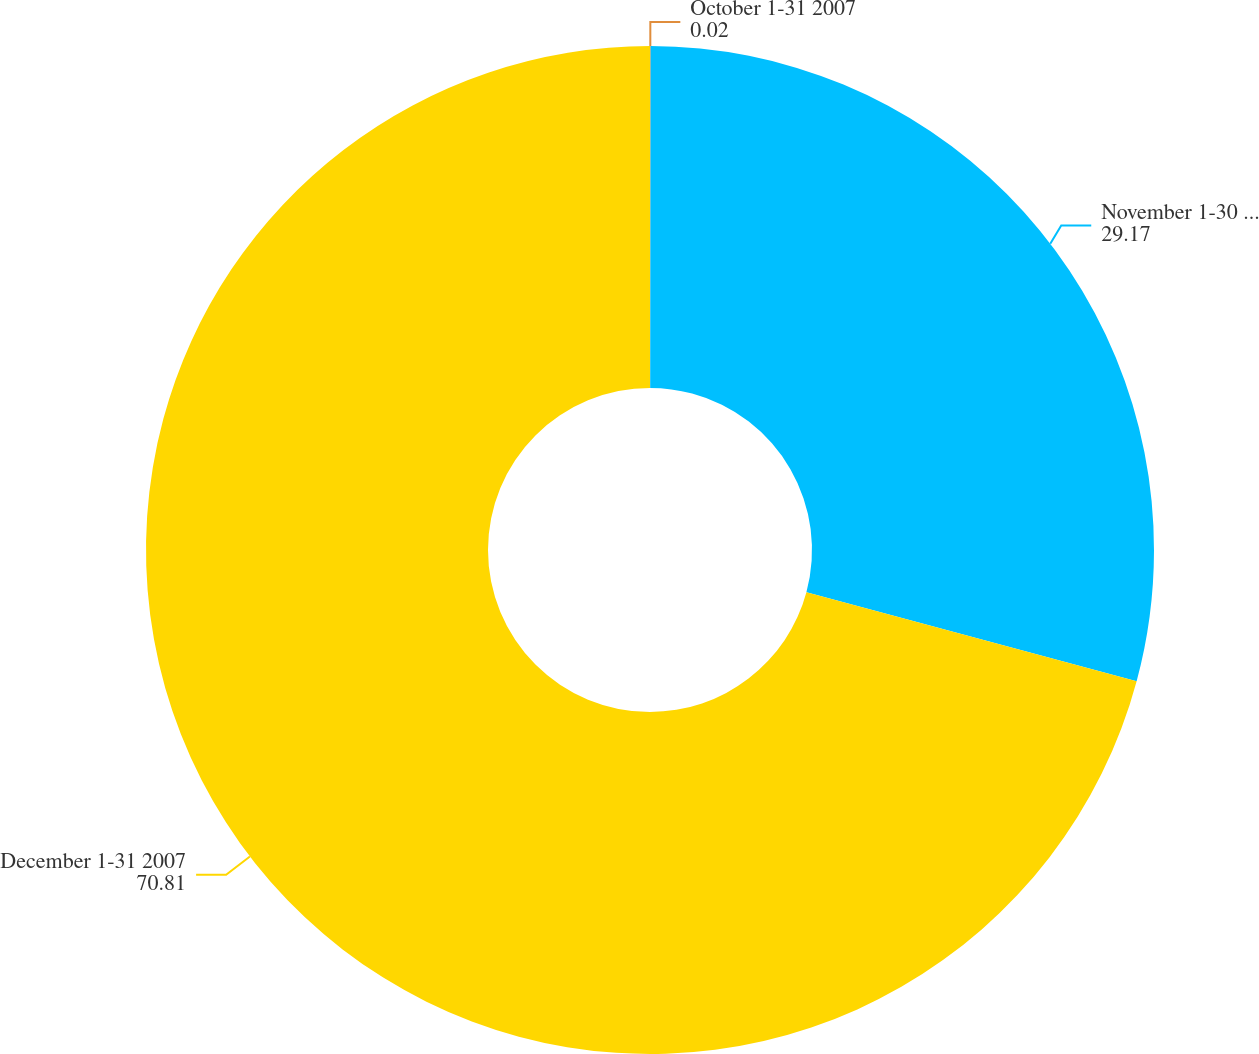Convert chart to OTSL. <chart><loc_0><loc_0><loc_500><loc_500><pie_chart><fcel>October 1-31 2007<fcel>November 1-30 2007<fcel>December 1-31 2007<nl><fcel>0.02%<fcel>29.17%<fcel>70.81%<nl></chart> 